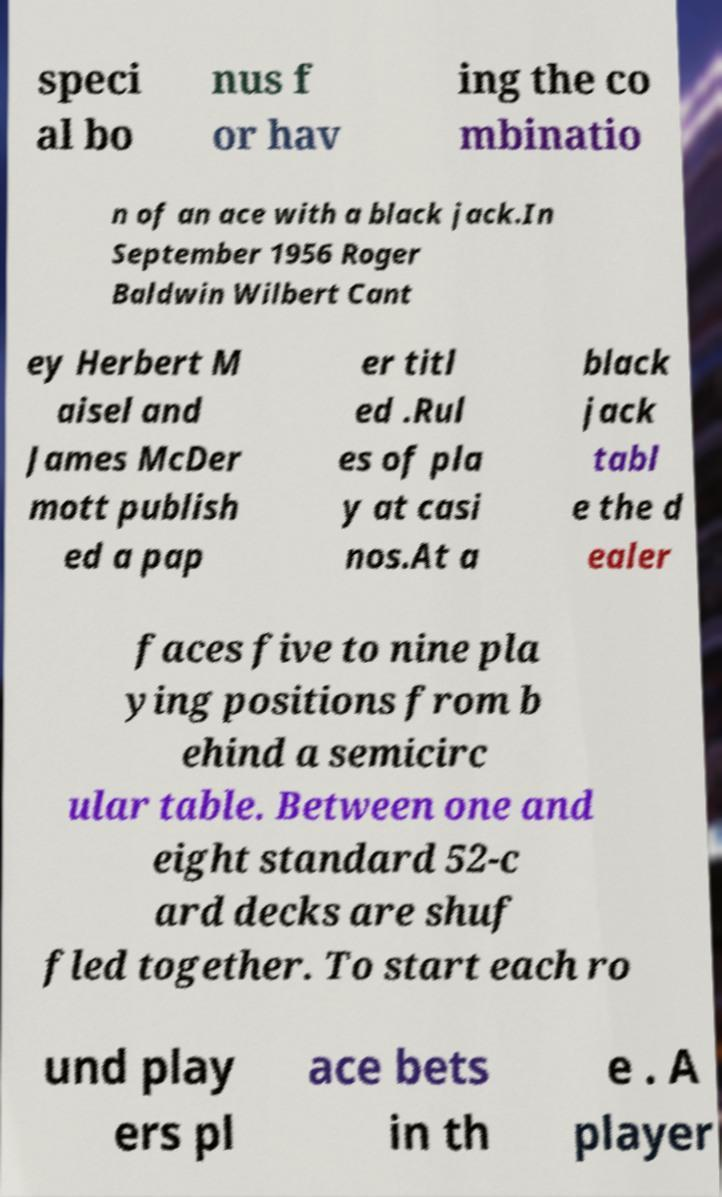I need the written content from this picture converted into text. Can you do that? speci al bo nus f or hav ing the co mbinatio n of an ace with a black jack.In September 1956 Roger Baldwin Wilbert Cant ey Herbert M aisel and James McDer mott publish ed a pap er titl ed .Rul es of pla y at casi nos.At a black jack tabl e the d ealer faces five to nine pla ying positions from b ehind a semicirc ular table. Between one and eight standard 52-c ard decks are shuf fled together. To start each ro und play ers pl ace bets in th e . A player 